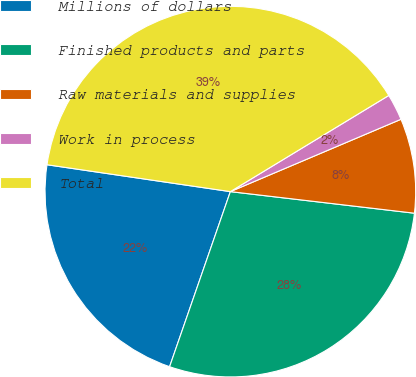Convert chart. <chart><loc_0><loc_0><loc_500><loc_500><pie_chart><fcel>Millions of dollars<fcel>Finished products and parts<fcel>Raw materials and supplies<fcel>Work in process<fcel>Total<nl><fcel>22.0%<fcel>28.46%<fcel>8.24%<fcel>2.3%<fcel>39.0%<nl></chart> 